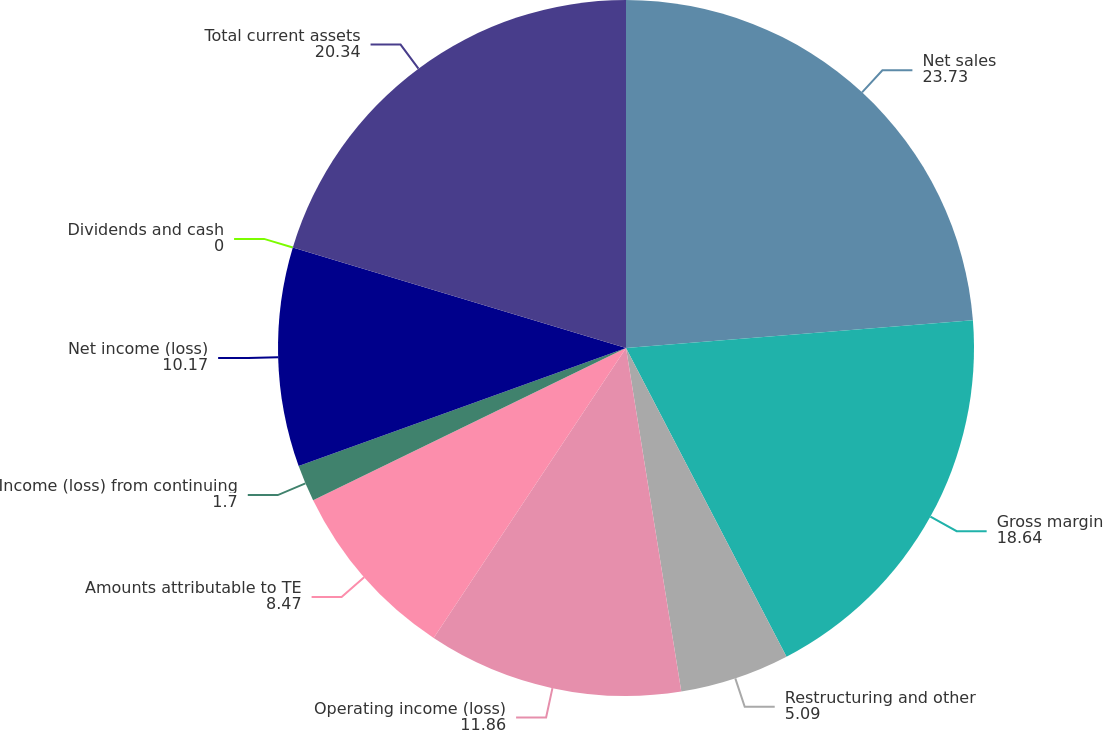Convert chart. <chart><loc_0><loc_0><loc_500><loc_500><pie_chart><fcel>Net sales<fcel>Gross margin<fcel>Restructuring and other<fcel>Operating income (loss)<fcel>Amounts attributable to TE<fcel>Income (loss) from continuing<fcel>Net income (loss)<fcel>Dividends and cash<fcel>Total current assets<nl><fcel>23.73%<fcel>18.64%<fcel>5.09%<fcel>11.86%<fcel>8.47%<fcel>1.7%<fcel>10.17%<fcel>0.0%<fcel>20.34%<nl></chart> 